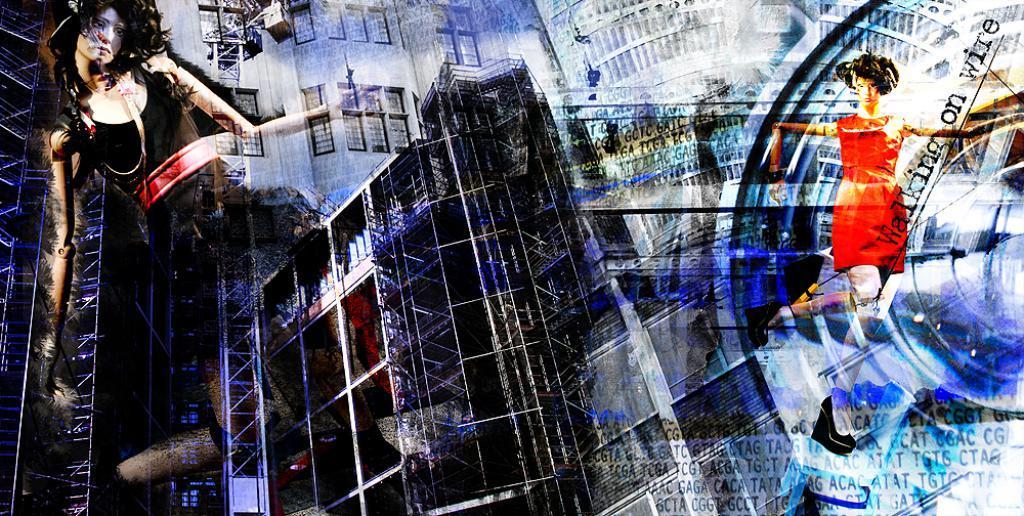Describe this image in one or two sentences. This is an edited image. There are depictions of girls in the image. 